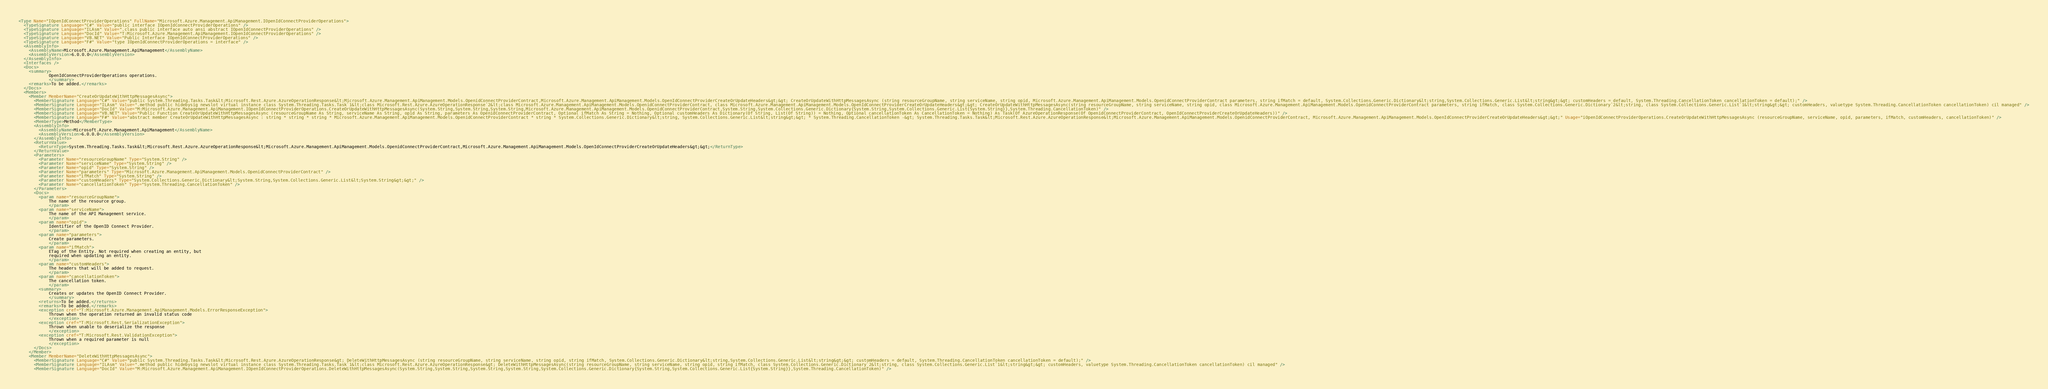Convert code to text. <code><loc_0><loc_0><loc_500><loc_500><_XML_><Type Name="IOpenIdConnectProviderOperations" FullName="Microsoft.Azure.Management.ApiManagement.IOpenIdConnectProviderOperations">
  <TypeSignature Language="C#" Value="public interface IOpenIdConnectProviderOperations" />
  <TypeSignature Language="ILAsm" Value=".class public interface auto ansi abstract IOpenIdConnectProviderOperations" />
  <TypeSignature Language="DocId" Value="T:Microsoft.Azure.Management.ApiManagement.IOpenIdConnectProviderOperations" />
  <TypeSignature Language="VB.NET" Value="Public Interface IOpenIdConnectProviderOperations" />
  <TypeSignature Language="F#" Value="type IOpenIdConnectProviderOperations = interface" />
  <AssemblyInfo>
    <AssemblyName>Microsoft.Azure.Management.ApiManagement</AssemblyName>
    <AssemblyVersion>6.0.0.0</AssemblyVersion>
  </AssemblyInfo>
  <Interfaces />
  <Docs>
    <summary>
            OpenIdConnectProviderOperations operations.
            </summary>
    <remarks>To be added.</remarks>
  </Docs>
  <Members>
    <Member MemberName="CreateOrUpdateWithHttpMessagesAsync">
      <MemberSignature Language="C#" Value="public System.Threading.Tasks.Task&lt;Microsoft.Rest.Azure.AzureOperationResponse&lt;Microsoft.Azure.Management.ApiManagement.Models.OpenidConnectProviderContract,Microsoft.Azure.Management.ApiManagement.Models.OpenIdConnectProviderCreateOrUpdateHeaders&gt;&gt; CreateOrUpdateWithHttpMessagesAsync (string resourceGroupName, string serviceName, string opid, Microsoft.Azure.Management.ApiManagement.Models.OpenidConnectProviderContract parameters, string ifMatch = default, System.Collections.Generic.Dictionary&lt;string,System.Collections.Generic.List&lt;string&gt;&gt; customHeaders = default, System.Threading.CancellationToken cancellationToken = default);" />
      <MemberSignature Language="ILAsm" Value=".method public hidebysig newslot virtual instance class System.Threading.Tasks.Task`1&lt;class Microsoft.Rest.Azure.AzureOperationResponse`2&lt;class Microsoft.Azure.Management.ApiManagement.Models.OpenidConnectProviderContract, class Microsoft.Azure.Management.ApiManagement.Models.OpenIdConnectProviderCreateOrUpdateHeaders&gt;&gt; CreateOrUpdateWithHttpMessagesAsync(string resourceGroupName, string serviceName, string opid, class Microsoft.Azure.Management.ApiManagement.Models.OpenidConnectProviderContract parameters, string ifMatch, class System.Collections.Generic.Dictionary`2&lt;string, class System.Collections.Generic.List`1&lt;string&gt;&gt; customHeaders, valuetype System.Threading.CancellationToken cancellationToken) cil managed" />
      <MemberSignature Language="DocId" Value="M:Microsoft.Azure.Management.ApiManagement.IOpenIdConnectProviderOperations.CreateOrUpdateWithHttpMessagesAsync(System.String,System.String,System.String,Microsoft.Azure.Management.ApiManagement.Models.OpenidConnectProviderContract,System.String,System.Collections.Generic.Dictionary{System.String,System.Collections.Generic.List{System.String}},System.Threading.CancellationToken)" />
      <MemberSignature Language="VB.NET" Value="Public Function CreateOrUpdateWithHttpMessagesAsync (resourceGroupName As String, serviceName As String, opid As String, parameters As OpenidConnectProviderContract, Optional ifMatch As String = Nothing, Optional customHeaders As Dictionary(Of String, List(Of String)) = Nothing, Optional cancellationToken As CancellationToken = Nothing) As Task(Of AzureOperationResponse(Of OpenidConnectProviderContract, OpenIdConnectProviderCreateOrUpdateHeaders))" />
      <MemberSignature Language="F#" Value="abstract member CreateOrUpdateWithHttpMessagesAsync : string * string * string * Microsoft.Azure.Management.ApiManagement.Models.OpenidConnectProviderContract * string * System.Collections.Generic.Dictionary&lt;string, System.Collections.Generic.List&lt;string&gt;&gt; * System.Threading.CancellationToken -&gt; System.Threading.Tasks.Task&lt;Microsoft.Rest.Azure.AzureOperationResponse&lt;Microsoft.Azure.Management.ApiManagement.Models.OpenidConnectProviderContract, Microsoft.Azure.Management.ApiManagement.Models.OpenIdConnectProviderCreateOrUpdateHeaders&gt;&gt;" Usage="iOpenIdConnectProviderOperations.CreateOrUpdateWithHttpMessagesAsync (resourceGroupName, serviceName, opid, parameters, ifMatch, customHeaders, cancellationToken)" />
      <MemberType>Method</MemberType>
      <AssemblyInfo>
        <AssemblyName>Microsoft.Azure.Management.ApiManagement</AssemblyName>
        <AssemblyVersion>6.0.0.0</AssemblyVersion>
      </AssemblyInfo>
      <ReturnValue>
        <ReturnType>System.Threading.Tasks.Task&lt;Microsoft.Rest.Azure.AzureOperationResponse&lt;Microsoft.Azure.Management.ApiManagement.Models.OpenidConnectProviderContract,Microsoft.Azure.Management.ApiManagement.Models.OpenIdConnectProviderCreateOrUpdateHeaders&gt;&gt;</ReturnType>
      </ReturnValue>
      <Parameters>
        <Parameter Name="resourceGroupName" Type="System.String" />
        <Parameter Name="serviceName" Type="System.String" />
        <Parameter Name="opid" Type="System.String" />
        <Parameter Name="parameters" Type="Microsoft.Azure.Management.ApiManagement.Models.OpenidConnectProviderContract" />
        <Parameter Name="ifMatch" Type="System.String" />
        <Parameter Name="customHeaders" Type="System.Collections.Generic.Dictionary&lt;System.String,System.Collections.Generic.List&lt;System.String&gt;&gt;" />
        <Parameter Name="cancellationToken" Type="System.Threading.CancellationToken" />
      </Parameters>
      <Docs>
        <param name="resourceGroupName">
            The name of the resource group.
            </param>
        <param name="serviceName">
            The name of the API Management service.
            </param>
        <param name="opid">
            Identifier of the OpenID Connect Provider.
            </param>
        <param name="parameters">
            Create parameters.
            </param>
        <param name="ifMatch">
            ETag of the Entity. Not required when creating an entity, but
            required when updating an entity.
            </param>
        <param name="customHeaders">
            The headers that will be added to request.
            </param>
        <param name="cancellationToken">
            The cancellation token.
            </param>
        <summary>
            Creates or updates the OpenID Connect Provider.
            </summary>
        <returns>To be added.</returns>
        <remarks>To be added.</remarks>
        <exception cref="T:Microsoft.Azure.Management.ApiManagement.Models.ErrorResponseException">
            Thrown when the operation returned an invalid status code
            </exception>
        <exception cref="T:Microsoft.Rest.SerializationException">
            Thrown when unable to deserialize the response
            </exception>
        <exception cref="T:Microsoft.Rest.ValidationException">
            Thrown when a required parameter is null
            </exception>
      </Docs>
    </Member>
    <Member MemberName="DeleteWithHttpMessagesAsync">
      <MemberSignature Language="C#" Value="public System.Threading.Tasks.Task&lt;Microsoft.Rest.Azure.AzureOperationResponse&gt; DeleteWithHttpMessagesAsync (string resourceGroupName, string serviceName, string opid, string ifMatch, System.Collections.Generic.Dictionary&lt;string,System.Collections.Generic.List&lt;string&gt;&gt; customHeaders = default, System.Threading.CancellationToken cancellationToken = default);" />
      <MemberSignature Language="ILAsm" Value=".method public hidebysig newslot virtual instance class System.Threading.Tasks.Task`1&lt;class Microsoft.Rest.Azure.AzureOperationResponse&gt; DeleteWithHttpMessagesAsync(string resourceGroupName, string serviceName, string opid, string ifMatch, class System.Collections.Generic.Dictionary`2&lt;string, class System.Collections.Generic.List`1&lt;string&gt;&gt; customHeaders, valuetype System.Threading.CancellationToken cancellationToken) cil managed" />
      <MemberSignature Language="DocId" Value="M:Microsoft.Azure.Management.ApiManagement.IOpenIdConnectProviderOperations.DeleteWithHttpMessagesAsync(System.String,System.String,System.String,System.String,System.Collections.Generic.Dictionary{System.String,System.Collections.Generic.List{System.String}},System.Threading.CancellationToken)" /></code> 